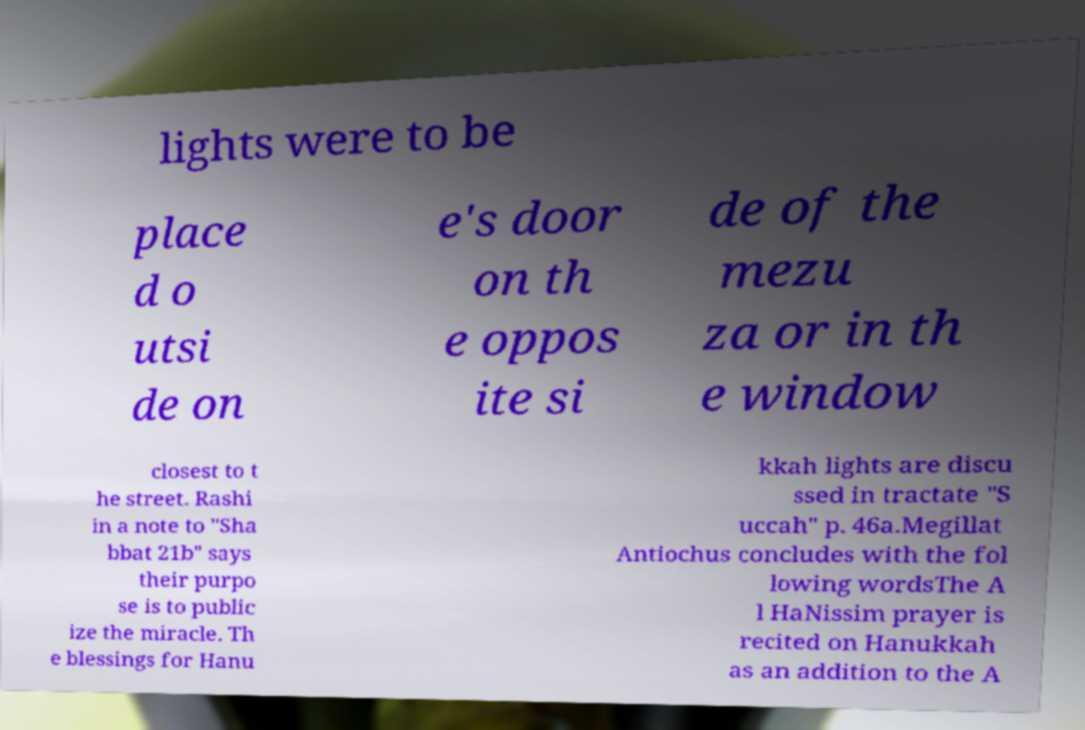Can you accurately transcribe the text from the provided image for me? lights were to be place d o utsi de on e's door on th e oppos ite si de of the mezu za or in th e window closest to t he street. Rashi in a note to "Sha bbat 21b" says their purpo se is to public ize the miracle. Th e blessings for Hanu kkah lights are discu ssed in tractate "S uccah" p. 46a.Megillat Antiochus concludes with the fol lowing wordsThe A l HaNissim prayer is recited on Hanukkah as an addition to the A 